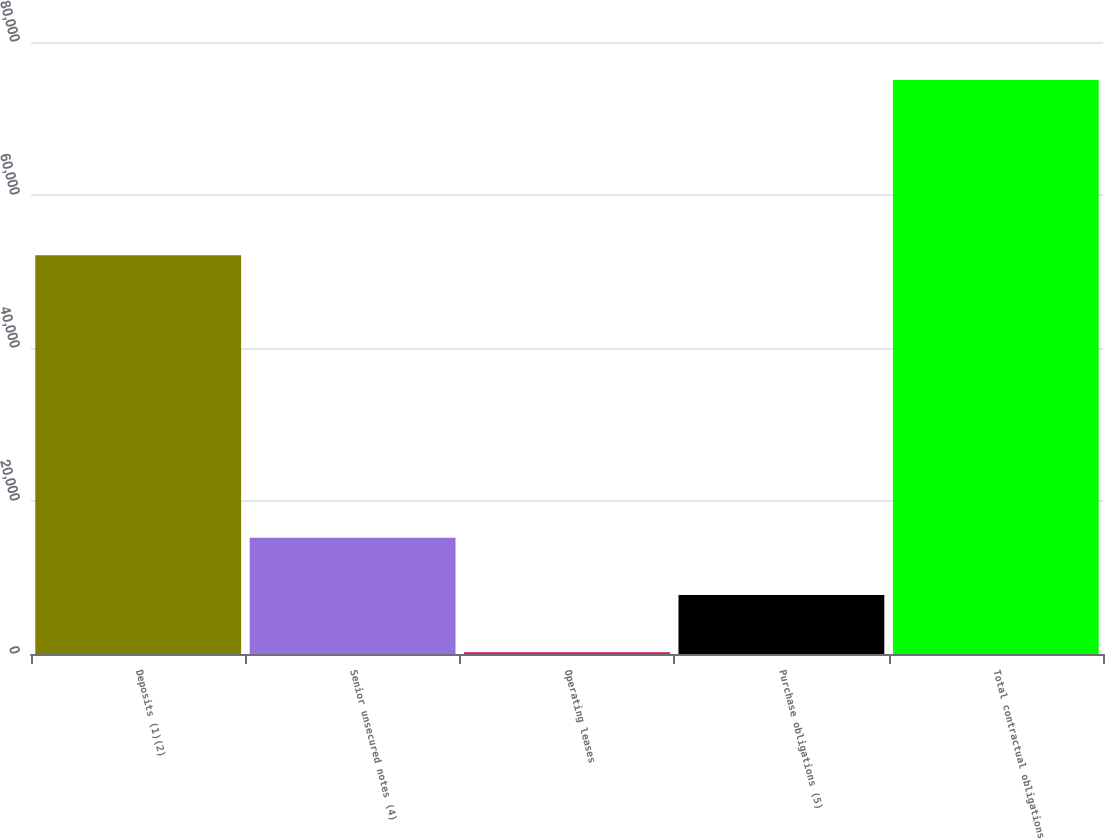Convert chart to OTSL. <chart><loc_0><loc_0><loc_500><loc_500><bar_chart><fcel>Deposits (1)(2)<fcel>Senior unsecured notes (4)<fcel>Operating leases<fcel>Purchase obligations (5)<fcel>Total contractual obligations<nl><fcel>52121<fcel>15196.4<fcel>235<fcel>7715.7<fcel>75042<nl></chart> 